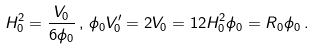Convert formula to latex. <formula><loc_0><loc_0><loc_500><loc_500>H _ { 0 } ^ { 2 } = \frac { V _ { 0 } } { 6 \phi _ { 0 } } \, , \, \phi _ { 0 } V _ { 0 } ^ { \prime } = 2 V _ { 0 } = 1 2 H _ { 0 } ^ { 2 } \phi _ { 0 } = R _ { 0 } \phi _ { 0 } \, .</formula> 